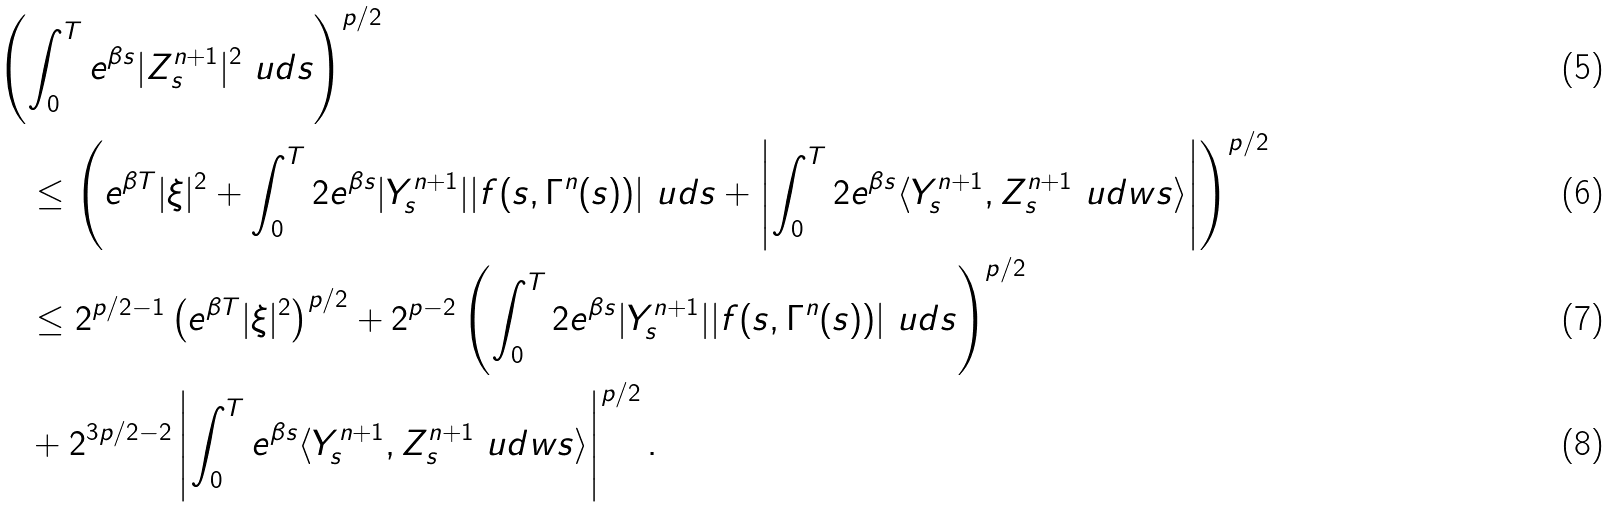Convert formula to latex. <formula><loc_0><loc_0><loc_500><loc_500>& \left ( \int _ { 0 } ^ { T } e ^ { \beta s } | Z ^ { n + 1 } _ { s } | ^ { 2 } \ u d s \right ) ^ { p / 2 } \\ & \quad \leq \left ( e ^ { \beta T } | \xi | ^ { 2 } + \int _ { 0 } ^ { T } 2 e ^ { \beta s } | Y ^ { n + 1 } _ { s } | | f ( s , \Gamma ^ { n } ( s ) ) | \ u d s + \left | \int _ { 0 } ^ { T } 2 e ^ { \beta s } \langle Y ^ { n + 1 } _ { s } , Z ^ { n + 1 } _ { s } \ u d w s \rangle \right | \right ) ^ { p / 2 } \\ & \quad \leq 2 ^ { p / 2 - 1 } \left ( e ^ { \beta T } | \xi | ^ { 2 } \right ) ^ { p / 2 } + 2 ^ { p - 2 } \left ( \int _ { 0 } ^ { T } 2 e ^ { \beta s } | Y ^ { n + 1 } _ { s } | | f ( s , \Gamma ^ { n } ( s ) ) | \ u d s \right ) ^ { p / 2 } \\ & \quad + 2 ^ { 3 p / 2 - 2 } \left | \int _ { 0 } ^ { T } e ^ { \beta s } \langle Y ^ { n + 1 } _ { s } , Z ^ { n + 1 } _ { s } \ u d w s \rangle \right | ^ { p / 2 } .</formula> 